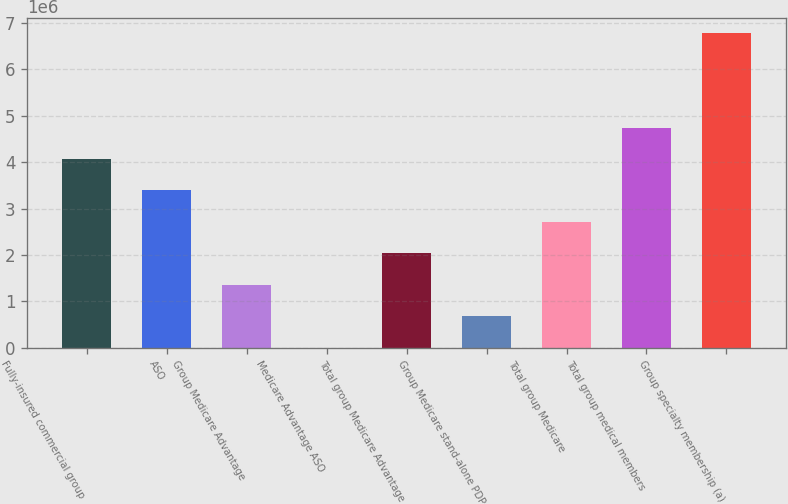Convert chart to OTSL. <chart><loc_0><loc_0><loc_500><loc_500><bar_chart><fcel>Fully-insured commercial group<fcel>ASO<fcel>Group Medicare Advantage<fcel>Medicare Advantage ASO<fcel>Total group Medicare Advantage<fcel>Group Medicare stand-alone PDP<fcel>Total group Medicare<fcel>Total group medical members<fcel>Group specialty membership (a)<nl><fcel>4.06848e+06<fcel>3.3904e+06<fcel>1.35616e+06<fcel>2.03<fcel>2.03424e+06<fcel>678082<fcel>2.71232e+06<fcel>4.74656e+06<fcel>6.7808e+06<nl></chart> 